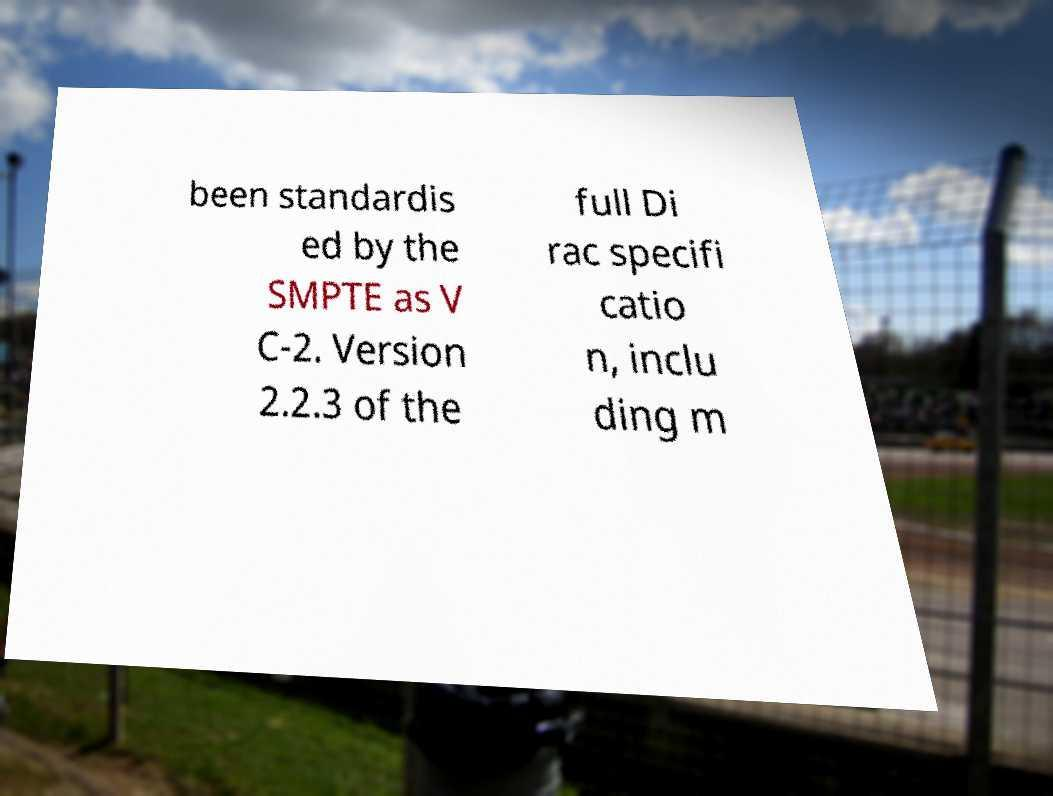Could you assist in decoding the text presented in this image and type it out clearly? been standardis ed by the SMPTE as V C-2. Version 2.2.3 of the full Di rac specifi catio n, inclu ding m 